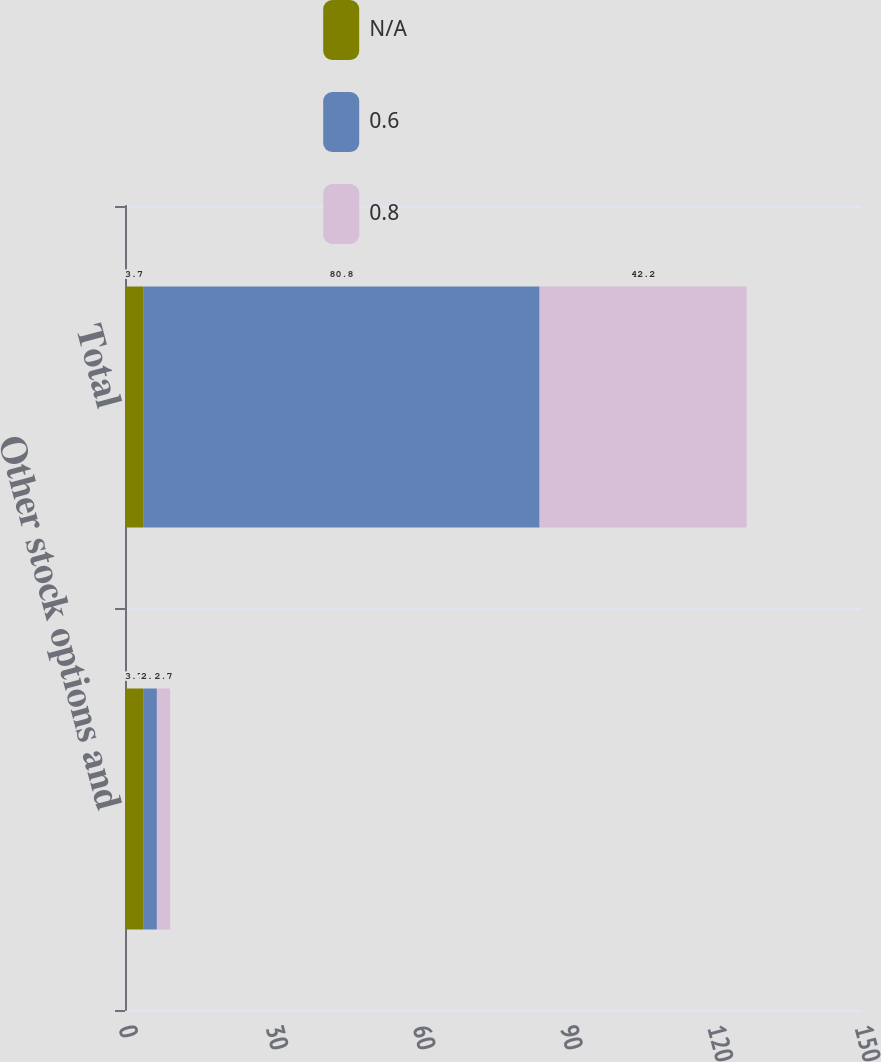Convert chart. <chart><loc_0><loc_0><loc_500><loc_500><stacked_bar_chart><ecel><fcel>Other stock options and<fcel>Total<nl><fcel>nan<fcel>3.7<fcel>3.7<nl><fcel>0.6<fcel>2.8<fcel>80.8<nl><fcel>0.8<fcel>2.7<fcel>42.2<nl></chart> 